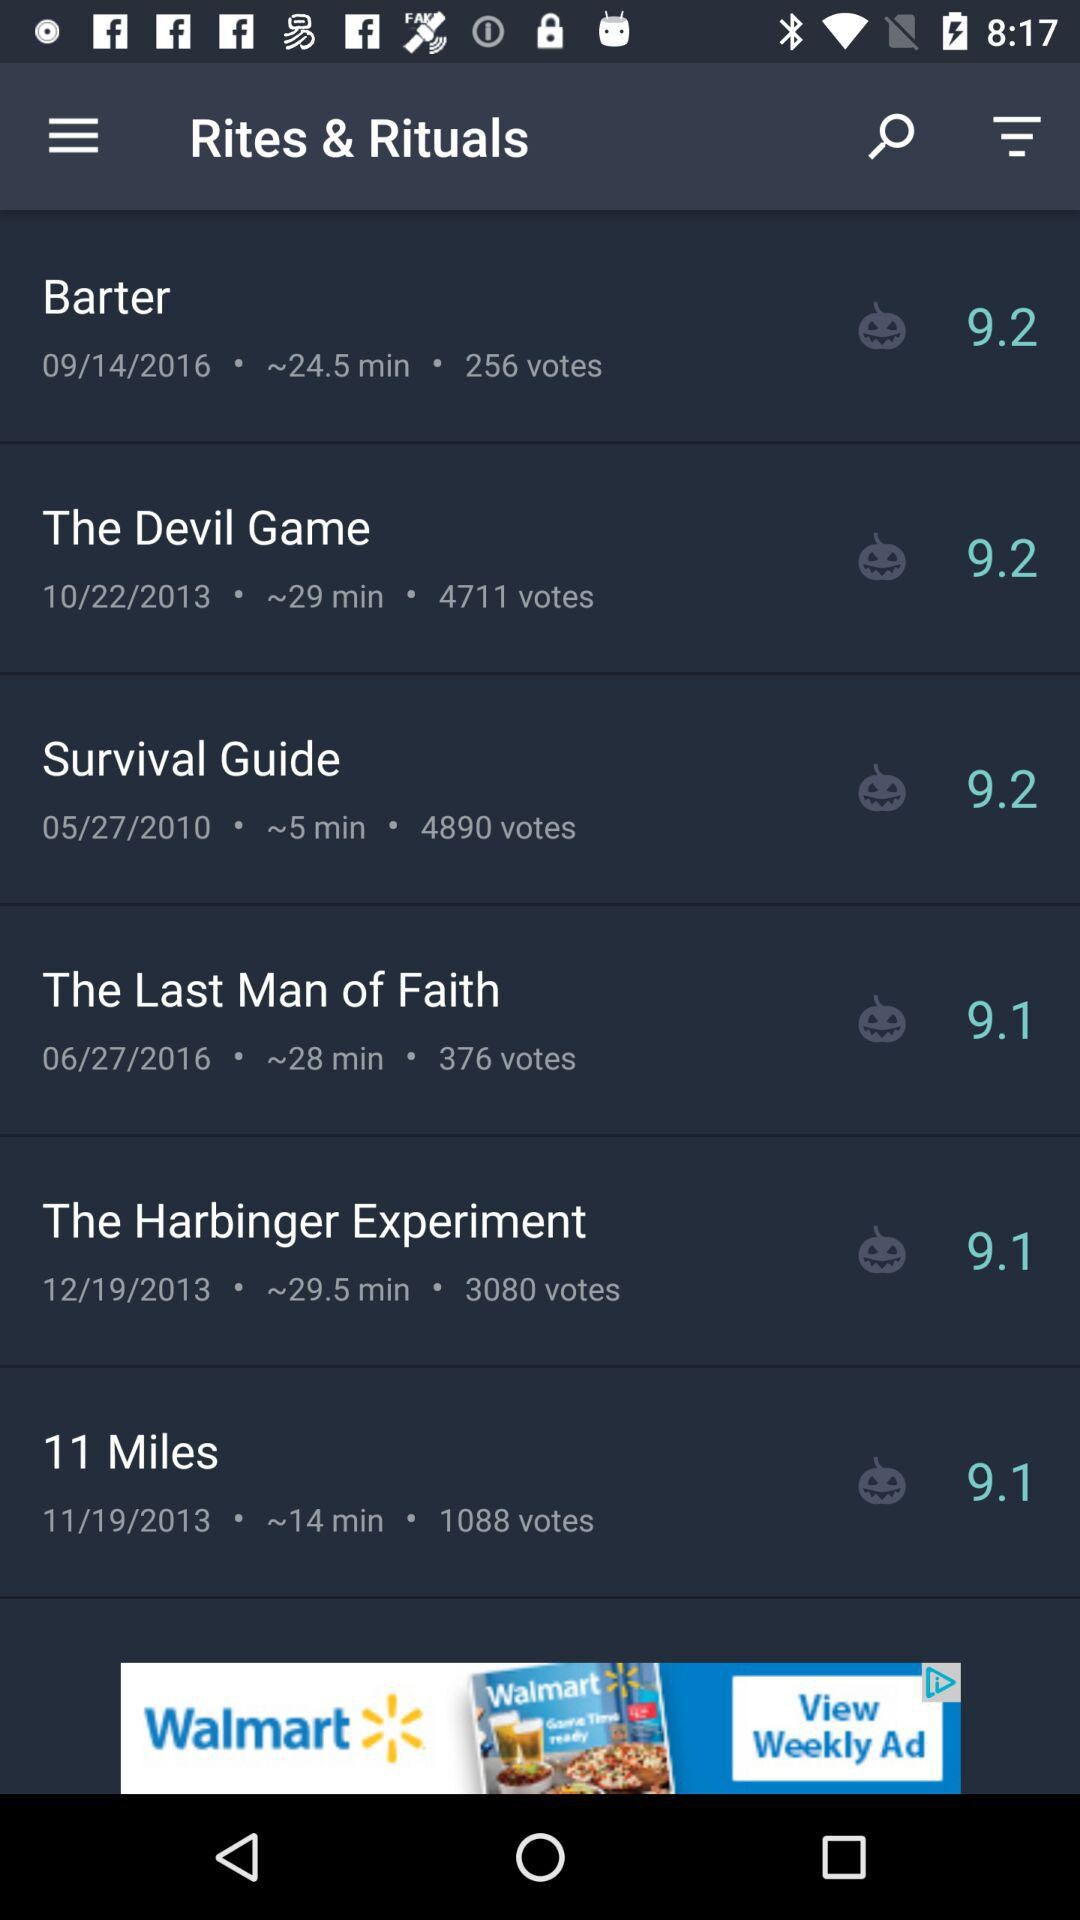What is the duration of the devil game? The duration is ~29 minutes. 